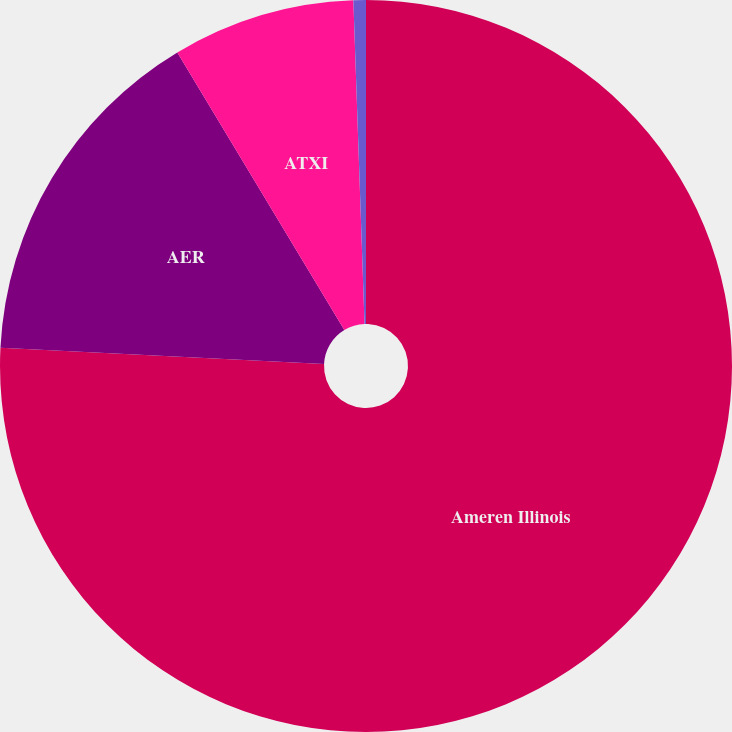<chart> <loc_0><loc_0><loc_500><loc_500><pie_chart><fcel>Ameren Illinois<fcel>AER<fcel>ATXI<fcel>Other (a)<nl><fcel>75.79%<fcel>15.59%<fcel>8.07%<fcel>0.55%<nl></chart> 